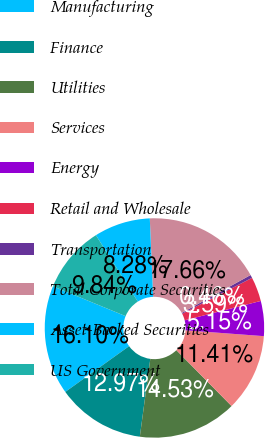<chart> <loc_0><loc_0><loc_500><loc_500><pie_chart><fcel>Manufacturing<fcel>Finance<fcel>Utilities<fcel>Services<fcel>Energy<fcel>Retail and Wholesale<fcel>Transportation<fcel>Total Corporate Securities<fcel>Asset-Backed Securities<fcel>US Government<nl><fcel>16.1%<fcel>12.97%<fcel>14.53%<fcel>11.41%<fcel>5.15%<fcel>3.59%<fcel>0.46%<fcel>17.66%<fcel>8.28%<fcel>9.84%<nl></chart> 